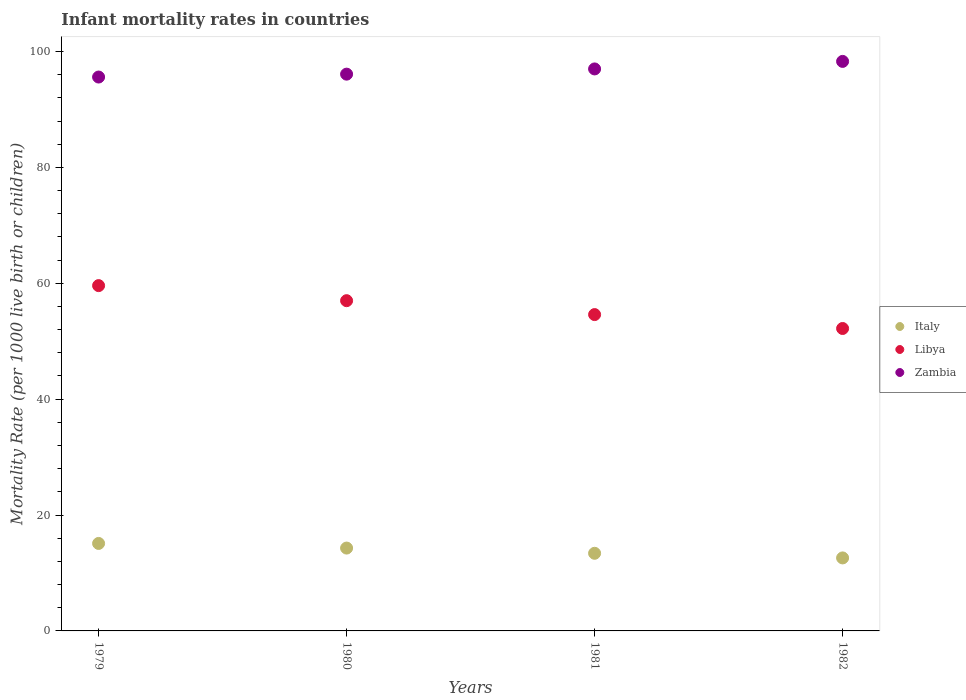How many different coloured dotlines are there?
Give a very brief answer. 3. Is the number of dotlines equal to the number of legend labels?
Offer a terse response. Yes. What is the infant mortality rate in Libya in 1982?
Provide a succinct answer. 52.2. Across all years, what is the maximum infant mortality rate in Libya?
Provide a succinct answer. 59.6. In which year was the infant mortality rate in Libya maximum?
Offer a terse response. 1979. In which year was the infant mortality rate in Zambia minimum?
Provide a succinct answer. 1979. What is the total infant mortality rate in Italy in the graph?
Give a very brief answer. 55.4. What is the difference between the infant mortality rate in Italy in 1979 and that in 1980?
Your response must be concise. 0.8. What is the difference between the infant mortality rate in Italy in 1979 and the infant mortality rate in Libya in 1980?
Your response must be concise. -41.9. What is the average infant mortality rate in Libya per year?
Make the answer very short. 55.85. In the year 1981, what is the difference between the infant mortality rate in Zambia and infant mortality rate in Italy?
Provide a short and direct response. 83.6. In how many years, is the infant mortality rate in Italy greater than 84?
Your answer should be very brief. 0. What is the ratio of the infant mortality rate in Libya in 1980 to that in 1982?
Your answer should be compact. 1.09. What is the difference between the highest and the second highest infant mortality rate in Libya?
Offer a very short reply. 2.6. What is the difference between the highest and the lowest infant mortality rate in Italy?
Your answer should be compact. 2.5. In how many years, is the infant mortality rate in Libya greater than the average infant mortality rate in Libya taken over all years?
Your answer should be compact. 2. Is the sum of the infant mortality rate in Italy in 1980 and 1981 greater than the maximum infant mortality rate in Libya across all years?
Offer a very short reply. No. Is the infant mortality rate in Zambia strictly greater than the infant mortality rate in Italy over the years?
Ensure brevity in your answer.  Yes. How many dotlines are there?
Ensure brevity in your answer.  3. How many years are there in the graph?
Keep it short and to the point. 4. Are the values on the major ticks of Y-axis written in scientific E-notation?
Give a very brief answer. No. How many legend labels are there?
Keep it short and to the point. 3. What is the title of the graph?
Provide a short and direct response. Infant mortality rates in countries. What is the label or title of the Y-axis?
Provide a succinct answer. Mortality Rate (per 1000 live birth or children). What is the Mortality Rate (per 1000 live birth or children) of Italy in 1979?
Make the answer very short. 15.1. What is the Mortality Rate (per 1000 live birth or children) in Libya in 1979?
Provide a succinct answer. 59.6. What is the Mortality Rate (per 1000 live birth or children) in Zambia in 1979?
Offer a terse response. 95.6. What is the Mortality Rate (per 1000 live birth or children) of Libya in 1980?
Ensure brevity in your answer.  57. What is the Mortality Rate (per 1000 live birth or children) in Zambia in 1980?
Offer a terse response. 96.1. What is the Mortality Rate (per 1000 live birth or children) of Libya in 1981?
Provide a succinct answer. 54.6. What is the Mortality Rate (per 1000 live birth or children) in Zambia in 1981?
Offer a terse response. 97. What is the Mortality Rate (per 1000 live birth or children) in Libya in 1982?
Provide a succinct answer. 52.2. What is the Mortality Rate (per 1000 live birth or children) of Zambia in 1982?
Make the answer very short. 98.3. Across all years, what is the maximum Mortality Rate (per 1000 live birth or children) of Libya?
Ensure brevity in your answer.  59.6. Across all years, what is the maximum Mortality Rate (per 1000 live birth or children) of Zambia?
Make the answer very short. 98.3. Across all years, what is the minimum Mortality Rate (per 1000 live birth or children) in Libya?
Make the answer very short. 52.2. Across all years, what is the minimum Mortality Rate (per 1000 live birth or children) in Zambia?
Your answer should be very brief. 95.6. What is the total Mortality Rate (per 1000 live birth or children) of Italy in the graph?
Your answer should be very brief. 55.4. What is the total Mortality Rate (per 1000 live birth or children) of Libya in the graph?
Your answer should be very brief. 223.4. What is the total Mortality Rate (per 1000 live birth or children) of Zambia in the graph?
Ensure brevity in your answer.  387. What is the difference between the Mortality Rate (per 1000 live birth or children) in Italy in 1979 and that in 1980?
Keep it short and to the point. 0.8. What is the difference between the Mortality Rate (per 1000 live birth or children) in Libya in 1979 and that in 1980?
Your response must be concise. 2.6. What is the difference between the Mortality Rate (per 1000 live birth or children) in Zambia in 1979 and that in 1980?
Ensure brevity in your answer.  -0.5. What is the difference between the Mortality Rate (per 1000 live birth or children) in Libya in 1979 and that in 1981?
Ensure brevity in your answer.  5. What is the difference between the Mortality Rate (per 1000 live birth or children) of Zambia in 1979 and that in 1981?
Your answer should be compact. -1.4. What is the difference between the Mortality Rate (per 1000 live birth or children) in Libya in 1979 and that in 1982?
Your answer should be very brief. 7.4. What is the difference between the Mortality Rate (per 1000 live birth or children) of Zambia in 1979 and that in 1982?
Your answer should be very brief. -2.7. What is the difference between the Mortality Rate (per 1000 live birth or children) of Libya in 1980 and that in 1981?
Provide a short and direct response. 2.4. What is the difference between the Mortality Rate (per 1000 live birth or children) of Italy in 1980 and that in 1982?
Provide a short and direct response. 1.7. What is the difference between the Mortality Rate (per 1000 live birth or children) in Libya in 1981 and that in 1982?
Make the answer very short. 2.4. What is the difference between the Mortality Rate (per 1000 live birth or children) of Zambia in 1981 and that in 1982?
Keep it short and to the point. -1.3. What is the difference between the Mortality Rate (per 1000 live birth or children) of Italy in 1979 and the Mortality Rate (per 1000 live birth or children) of Libya in 1980?
Keep it short and to the point. -41.9. What is the difference between the Mortality Rate (per 1000 live birth or children) of Italy in 1979 and the Mortality Rate (per 1000 live birth or children) of Zambia in 1980?
Your answer should be very brief. -81. What is the difference between the Mortality Rate (per 1000 live birth or children) in Libya in 1979 and the Mortality Rate (per 1000 live birth or children) in Zambia in 1980?
Offer a very short reply. -36.5. What is the difference between the Mortality Rate (per 1000 live birth or children) in Italy in 1979 and the Mortality Rate (per 1000 live birth or children) in Libya in 1981?
Offer a terse response. -39.5. What is the difference between the Mortality Rate (per 1000 live birth or children) in Italy in 1979 and the Mortality Rate (per 1000 live birth or children) in Zambia in 1981?
Give a very brief answer. -81.9. What is the difference between the Mortality Rate (per 1000 live birth or children) in Libya in 1979 and the Mortality Rate (per 1000 live birth or children) in Zambia in 1981?
Your answer should be compact. -37.4. What is the difference between the Mortality Rate (per 1000 live birth or children) of Italy in 1979 and the Mortality Rate (per 1000 live birth or children) of Libya in 1982?
Make the answer very short. -37.1. What is the difference between the Mortality Rate (per 1000 live birth or children) of Italy in 1979 and the Mortality Rate (per 1000 live birth or children) of Zambia in 1982?
Offer a very short reply. -83.2. What is the difference between the Mortality Rate (per 1000 live birth or children) in Libya in 1979 and the Mortality Rate (per 1000 live birth or children) in Zambia in 1982?
Make the answer very short. -38.7. What is the difference between the Mortality Rate (per 1000 live birth or children) of Italy in 1980 and the Mortality Rate (per 1000 live birth or children) of Libya in 1981?
Give a very brief answer. -40.3. What is the difference between the Mortality Rate (per 1000 live birth or children) of Italy in 1980 and the Mortality Rate (per 1000 live birth or children) of Zambia in 1981?
Offer a very short reply. -82.7. What is the difference between the Mortality Rate (per 1000 live birth or children) of Libya in 1980 and the Mortality Rate (per 1000 live birth or children) of Zambia in 1981?
Your answer should be very brief. -40. What is the difference between the Mortality Rate (per 1000 live birth or children) in Italy in 1980 and the Mortality Rate (per 1000 live birth or children) in Libya in 1982?
Offer a terse response. -37.9. What is the difference between the Mortality Rate (per 1000 live birth or children) of Italy in 1980 and the Mortality Rate (per 1000 live birth or children) of Zambia in 1982?
Your answer should be very brief. -84. What is the difference between the Mortality Rate (per 1000 live birth or children) of Libya in 1980 and the Mortality Rate (per 1000 live birth or children) of Zambia in 1982?
Ensure brevity in your answer.  -41.3. What is the difference between the Mortality Rate (per 1000 live birth or children) of Italy in 1981 and the Mortality Rate (per 1000 live birth or children) of Libya in 1982?
Ensure brevity in your answer.  -38.8. What is the difference between the Mortality Rate (per 1000 live birth or children) of Italy in 1981 and the Mortality Rate (per 1000 live birth or children) of Zambia in 1982?
Offer a very short reply. -84.9. What is the difference between the Mortality Rate (per 1000 live birth or children) in Libya in 1981 and the Mortality Rate (per 1000 live birth or children) in Zambia in 1982?
Give a very brief answer. -43.7. What is the average Mortality Rate (per 1000 live birth or children) of Italy per year?
Provide a short and direct response. 13.85. What is the average Mortality Rate (per 1000 live birth or children) in Libya per year?
Offer a terse response. 55.85. What is the average Mortality Rate (per 1000 live birth or children) in Zambia per year?
Offer a terse response. 96.75. In the year 1979, what is the difference between the Mortality Rate (per 1000 live birth or children) in Italy and Mortality Rate (per 1000 live birth or children) in Libya?
Keep it short and to the point. -44.5. In the year 1979, what is the difference between the Mortality Rate (per 1000 live birth or children) in Italy and Mortality Rate (per 1000 live birth or children) in Zambia?
Make the answer very short. -80.5. In the year 1979, what is the difference between the Mortality Rate (per 1000 live birth or children) in Libya and Mortality Rate (per 1000 live birth or children) in Zambia?
Your answer should be very brief. -36. In the year 1980, what is the difference between the Mortality Rate (per 1000 live birth or children) of Italy and Mortality Rate (per 1000 live birth or children) of Libya?
Offer a very short reply. -42.7. In the year 1980, what is the difference between the Mortality Rate (per 1000 live birth or children) of Italy and Mortality Rate (per 1000 live birth or children) of Zambia?
Provide a succinct answer. -81.8. In the year 1980, what is the difference between the Mortality Rate (per 1000 live birth or children) in Libya and Mortality Rate (per 1000 live birth or children) in Zambia?
Your answer should be compact. -39.1. In the year 1981, what is the difference between the Mortality Rate (per 1000 live birth or children) in Italy and Mortality Rate (per 1000 live birth or children) in Libya?
Your answer should be compact. -41.2. In the year 1981, what is the difference between the Mortality Rate (per 1000 live birth or children) in Italy and Mortality Rate (per 1000 live birth or children) in Zambia?
Provide a short and direct response. -83.6. In the year 1981, what is the difference between the Mortality Rate (per 1000 live birth or children) in Libya and Mortality Rate (per 1000 live birth or children) in Zambia?
Your answer should be compact. -42.4. In the year 1982, what is the difference between the Mortality Rate (per 1000 live birth or children) in Italy and Mortality Rate (per 1000 live birth or children) in Libya?
Your answer should be very brief. -39.6. In the year 1982, what is the difference between the Mortality Rate (per 1000 live birth or children) of Italy and Mortality Rate (per 1000 live birth or children) of Zambia?
Ensure brevity in your answer.  -85.7. In the year 1982, what is the difference between the Mortality Rate (per 1000 live birth or children) in Libya and Mortality Rate (per 1000 live birth or children) in Zambia?
Provide a short and direct response. -46.1. What is the ratio of the Mortality Rate (per 1000 live birth or children) in Italy in 1979 to that in 1980?
Make the answer very short. 1.06. What is the ratio of the Mortality Rate (per 1000 live birth or children) in Libya in 1979 to that in 1980?
Offer a very short reply. 1.05. What is the ratio of the Mortality Rate (per 1000 live birth or children) of Zambia in 1979 to that in 1980?
Your answer should be very brief. 0.99. What is the ratio of the Mortality Rate (per 1000 live birth or children) of Italy in 1979 to that in 1981?
Provide a succinct answer. 1.13. What is the ratio of the Mortality Rate (per 1000 live birth or children) of Libya in 1979 to that in 1981?
Provide a succinct answer. 1.09. What is the ratio of the Mortality Rate (per 1000 live birth or children) of Zambia in 1979 to that in 1981?
Offer a very short reply. 0.99. What is the ratio of the Mortality Rate (per 1000 live birth or children) of Italy in 1979 to that in 1982?
Your answer should be very brief. 1.2. What is the ratio of the Mortality Rate (per 1000 live birth or children) of Libya in 1979 to that in 1982?
Keep it short and to the point. 1.14. What is the ratio of the Mortality Rate (per 1000 live birth or children) of Zambia in 1979 to that in 1982?
Provide a short and direct response. 0.97. What is the ratio of the Mortality Rate (per 1000 live birth or children) of Italy in 1980 to that in 1981?
Your answer should be very brief. 1.07. What is the ratio of the Mortality Rate (per 1000 live birth or children) of Libya in 1980 to that in 1981?
Your response must be concise. 1.04. What is the ratio of the Mortality Rate (per 1000 live birth or children) in Zambia in 1980 to that in 1981?
Ensure brevity in your answer.  0.99. What is the ratio of the Mortality Rate (per 1000 live birth or children) of Italy in 1980 to that in 1982?
Ensure brevity in your answer.  1.13. What is the ratio of the Mortality Rate (per 1000 live birth or children) of Libya in 1980 to that in 1982?
Provide a succinct answer. 1.09. What is the ratio of the Mortality Rate (per 1000 live birth or children) of Zambia in 1980 to that in 1982?
Provide a succinct answer. 0.98. What is the ratio of the Mortality Rate (per 1000 live birth or children) in Italy in 1981 to that in 1982?
Your response must be concise. 1.06. What is the ratio of the Mortality Rate (per 1000 live birth or children) in Libya in 1981 to that in 1982?
Your response must be concise. 1.05. What is the ratio of the Mortality Rate (per 1000 live birth or children) of Zambia in 1981 to that in 1982?
Your answer should be compact. 0.99. What is the difference between the highest and the second highest Mortality Rate (per 1000 live birth or children) of Italy?
Offer a terse response. 0.8. What is the difference between the highest and the second highest Mortality Rate (per 1000 live birth or children) of Libya?
Provide a short and direct response. 2.6. What is the difference between the highest and the second highest Mortality Rate (per 1000 live birth or children) of Zambia?
Your answer should be very brief. 1.3. What is the difference between the highest and the lowest Mortality Rate (per 1000 live birth or children) of Italy?
Give a very brief answer. 2.5. 